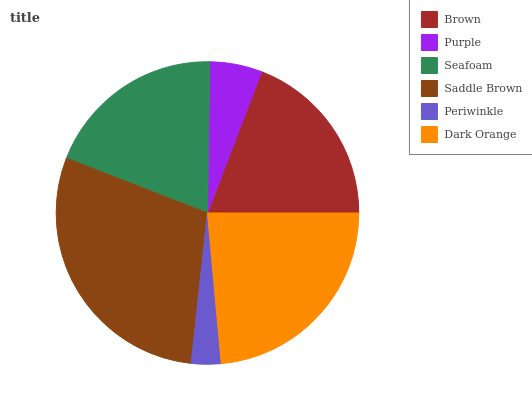Is Periwinkle the minimum?
Answer yes or no. Yes. Is Saddle Brown the maximum?
Answer yes or no. Yes. Is Purple the minimum?
Answer yes or no. No. Is Purple the maximum?
Answer yes or no. No. Is Brown greater than Purple?
Answer yes or no. Yes. Is Purple less than Brown?
Answer yes or no. Yes. Is Purple greater than Brown?
Answer yes or no. No. Is Brown less than Purple?
Answer yes or no. No. Is Seafoam the high median?
Answer yes or no. Yes. Is Brown the low median?
Answer yes or no. Yes. Is Periwinkle the high median?
Answer yes or no. No. Is Periwinkle the low median?
Answer yes or no. No. 